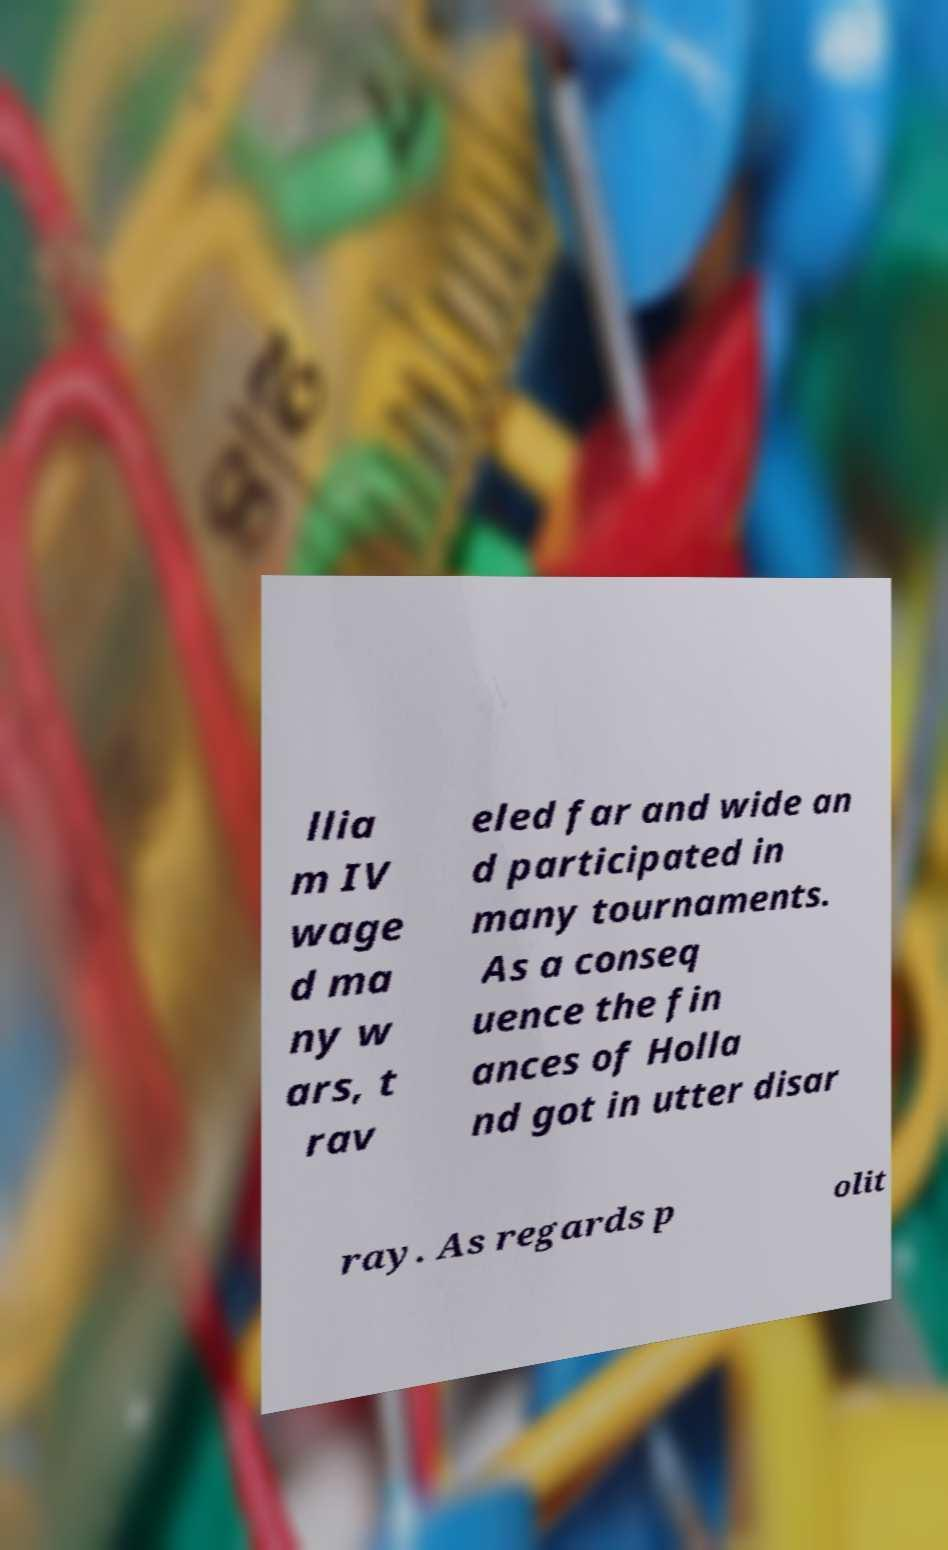Please read and relay the text visible in this image. What does it say? llia m IV wage d ma ny w ars, t rav eled far and wide an d participated in many tournaments. As a conseq uence the fin ances of Holla nd got in utter disar ray. As regards p olit 